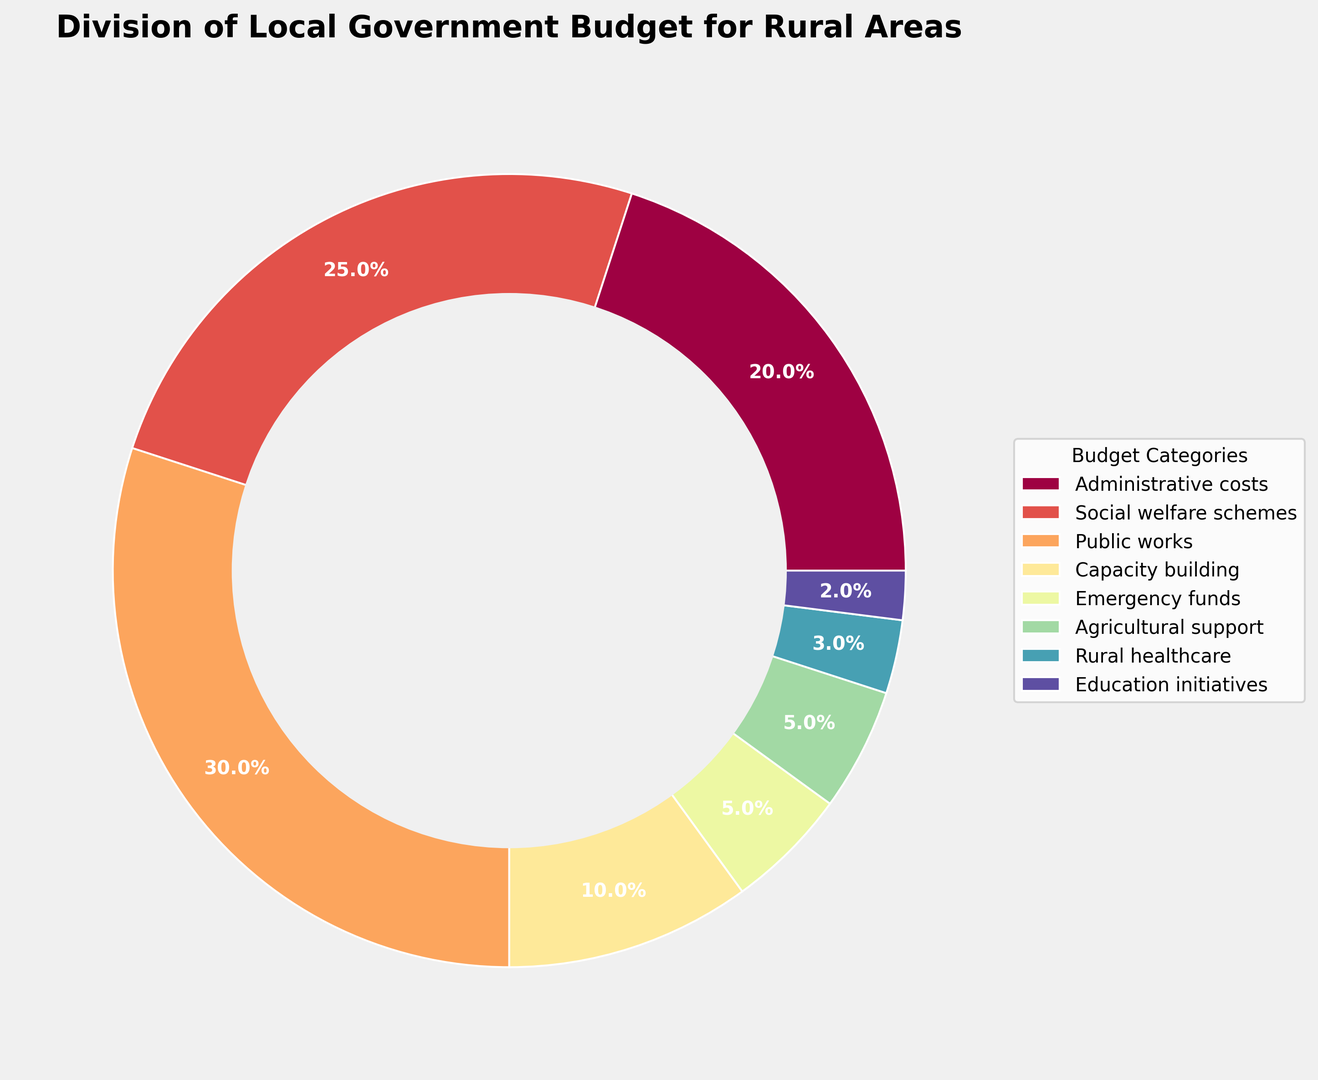What is the largest budget category? The ring chart shows the division of the local government budget for rural areas in different segments. Each segment represents a budget category, with its size and percentage labeled. The largest segment is "Public works" with 30%.
Answer: Public works What is the combined percentage for emergency funds and agricultural support? To determine the combined percentage, add the percentages for emergency funds (5%) and agricultural support (5%). 5% + 5% = 10%.
Answer: 10% Which category has a smaller budget allocation: education initiatives or rural healthcare? By comparing the percentages of the two categories, education initiatives have 2% and rural healthcare has 3%. Since 2% is smaller than 3%, education initiatives have a smaller budget allocation.
Answer: Education initiatives How does the budget for social welfare schemes compare to the budget for administrative costs? Social welfare schemes have 25%, while administrative costs have 20%. 25% is greater than 20%, so the budget for social welfare schemes is larger than that for administrative costs.
Answer: Social welfare schemes What is the total percentage allocated to categories related to health and education combined? Categories related to health and education are rural healthcare (3%) and education initiatives (2%). Summing these up yields 3% + 2% = 5%.
Answer: 5% What is the difference in budget allocation between public works and capacity building? Public works have a 30% allocation, and capacity building has a 10% allocation. The difference is 30% - 10% = 20%.
Answer: 20% Which category is depicted with the smallest segment in the plot? By looking at the visual segments in the ring chart, the smallest segment corresponds to education initiatives with 2%.
Answer: Education initiatives Adding up, what portion of the budget is allocated to non-administrative activities? Non-administrative activities include all categories except administrative costs. Adding the percentages: 25% (social welfare schemes) + 30% (public works) + 10% (capacity building) + 5% (emergency funds) + 5% (agricultural support) + 3% (rural healthcare) + 2% (education initiatives) = 80%.
Answer: 80% What is the combined budget for categories dedicated to infrastructure and emergency responses? Infrastructure-related category is public works (30%) and emergency responses is emergency funds (5%). Adding these gives 30% + 5% = 35%.
Answer: 35% Is the budget for capacity building greater than 10%? The ring chart shows the capacity-building segment labeled with 10% which means it is equal to but not greater than 10%.
Answer: No 